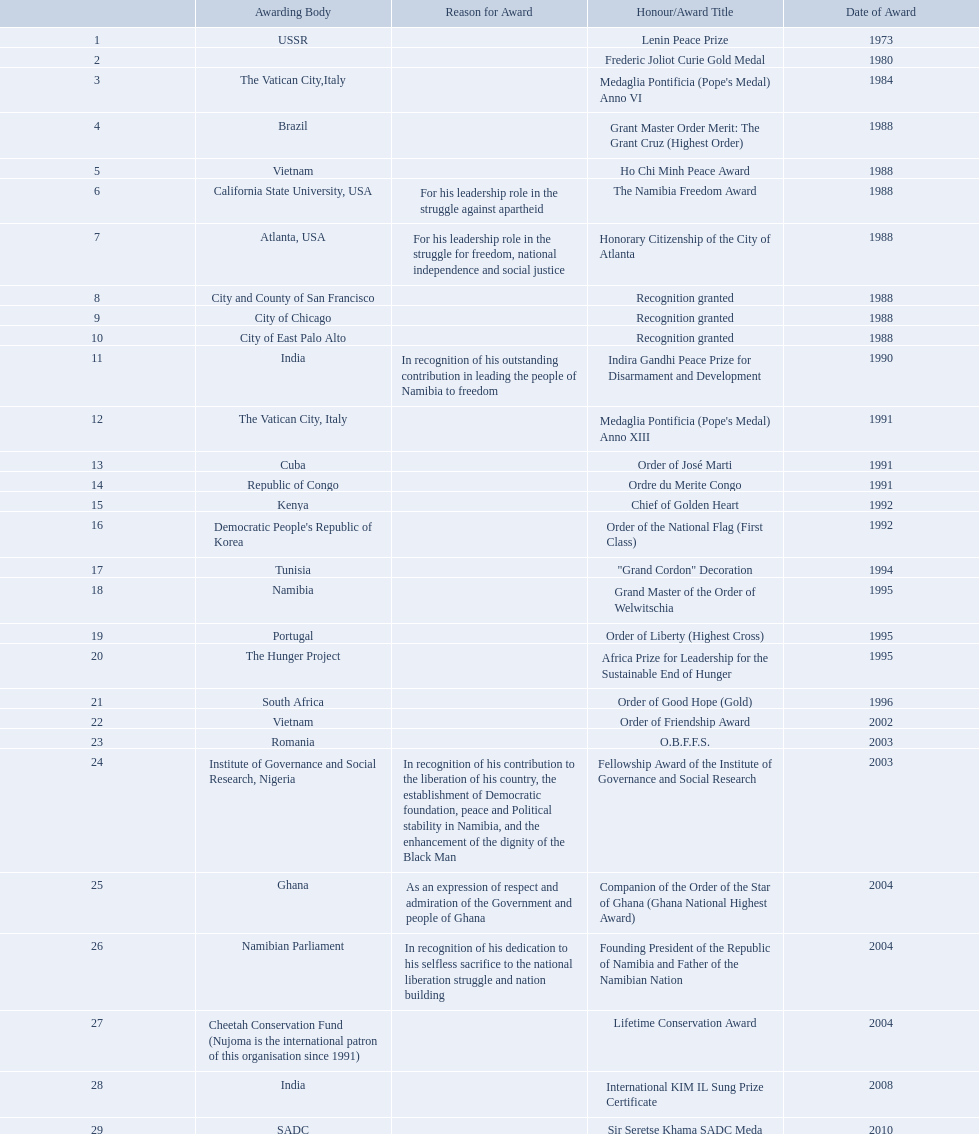What awards has sam nujoma been awarded? Lenin Peace Prize, Frederic Joliot Curie Gold Medal, Medaglia Pontificia (Pope's Medal) Anno VI, Grant Master Order Merit: The Grant Cruz (Highest Order), Ho Chi Minh Peace Award, The Namibia Freedom Award, Honorary Citizenship of the City of Atlanta, Recognition granted, Recognition granted, Recognition granted, Indira Gandhi Peace Prize for Disarmament and Development, Medaglia Pontificia (Pope's Medal) Anno XIII, Order of José Marti, Ordre du Merite Congo, Chief of Golden Heart, Order of the National Flag (First Class), "Grand Cordon" Decoration, Grand Master of the Order of Welwitschia, Order of Liberty (Highest Cross), Africa Prize for Leadership for the Sustainable End of Hunger, Order of Good Hope (Gold), Order of Friendship Award, O.B.F.F.S., Fellowship Award of the Institute of Governance and Social Research, Companion of the Order of the Star of Ghana (Ghana National Highest Award), Founding President of the Republic of Namibia and Father of the Namibian Nation, Lifetime Conservation Award, International KIM IL Sung Prize Certificate, Sir Seretse Khama SADC Meda. By which awarding body did sam nujoma receive the o.b.f.f.s award? Romania. 